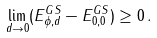<formula> <loc_0><loc_0><loc_500><loc_500>\lim _ { d \to 0 } ( E ^ { G S } _ { \phi , d } - E ^ { G S } _ { 0 , 0 } ) \geq 0 \, .</formula> 